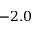Convert formula to latex. <formula><loc_0><loc_0><loc_500><loc_500>- 2 . 0</formula> 